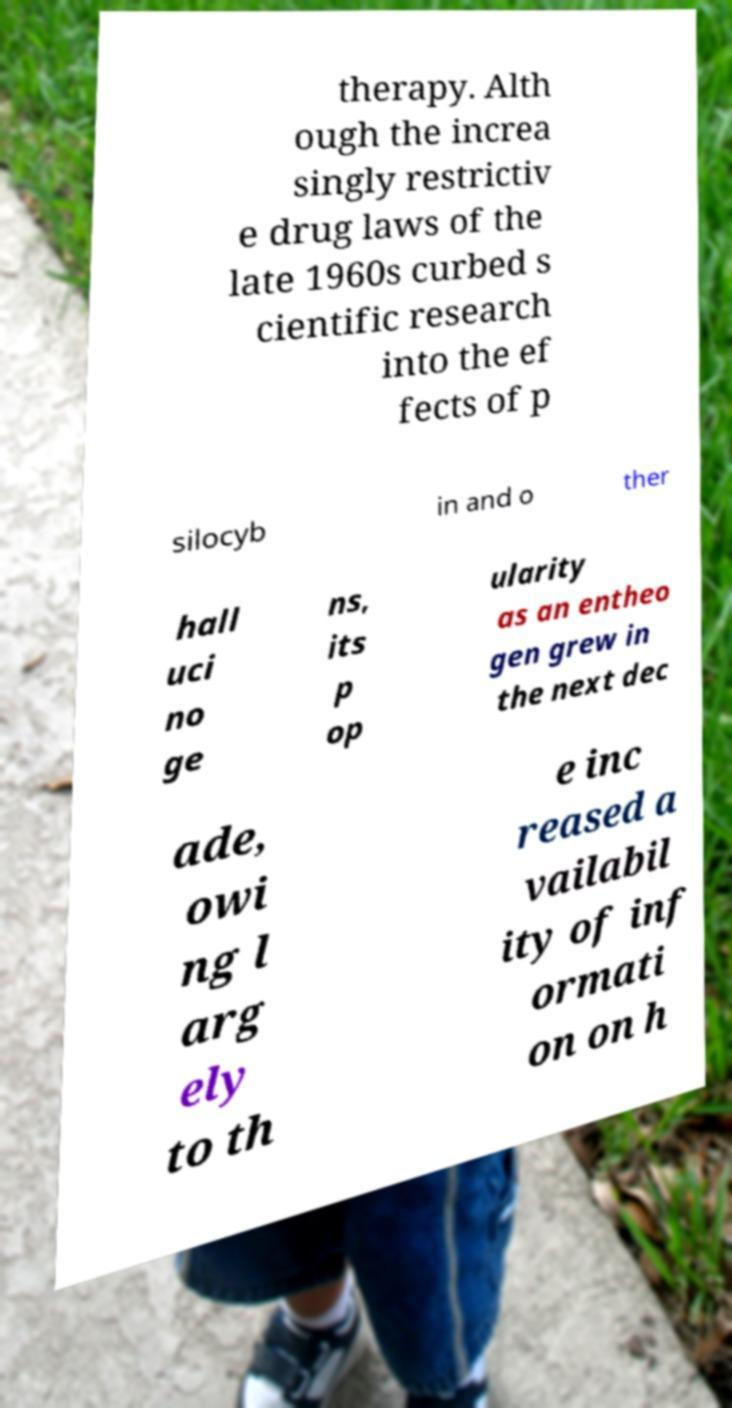Please identify and transcribe the text found in this image. therapy. Alth ough the increa singly restrictiv e drug laws of the late 1960s curbed s cientific research into the ef fects of p silocyb in and o ther hall uci no ge ns, its p op ularity as an entheo gen grew in the next dec ade, owi ng l arg ely to th e inc reased a vailabil ity of inf ormati on on h 